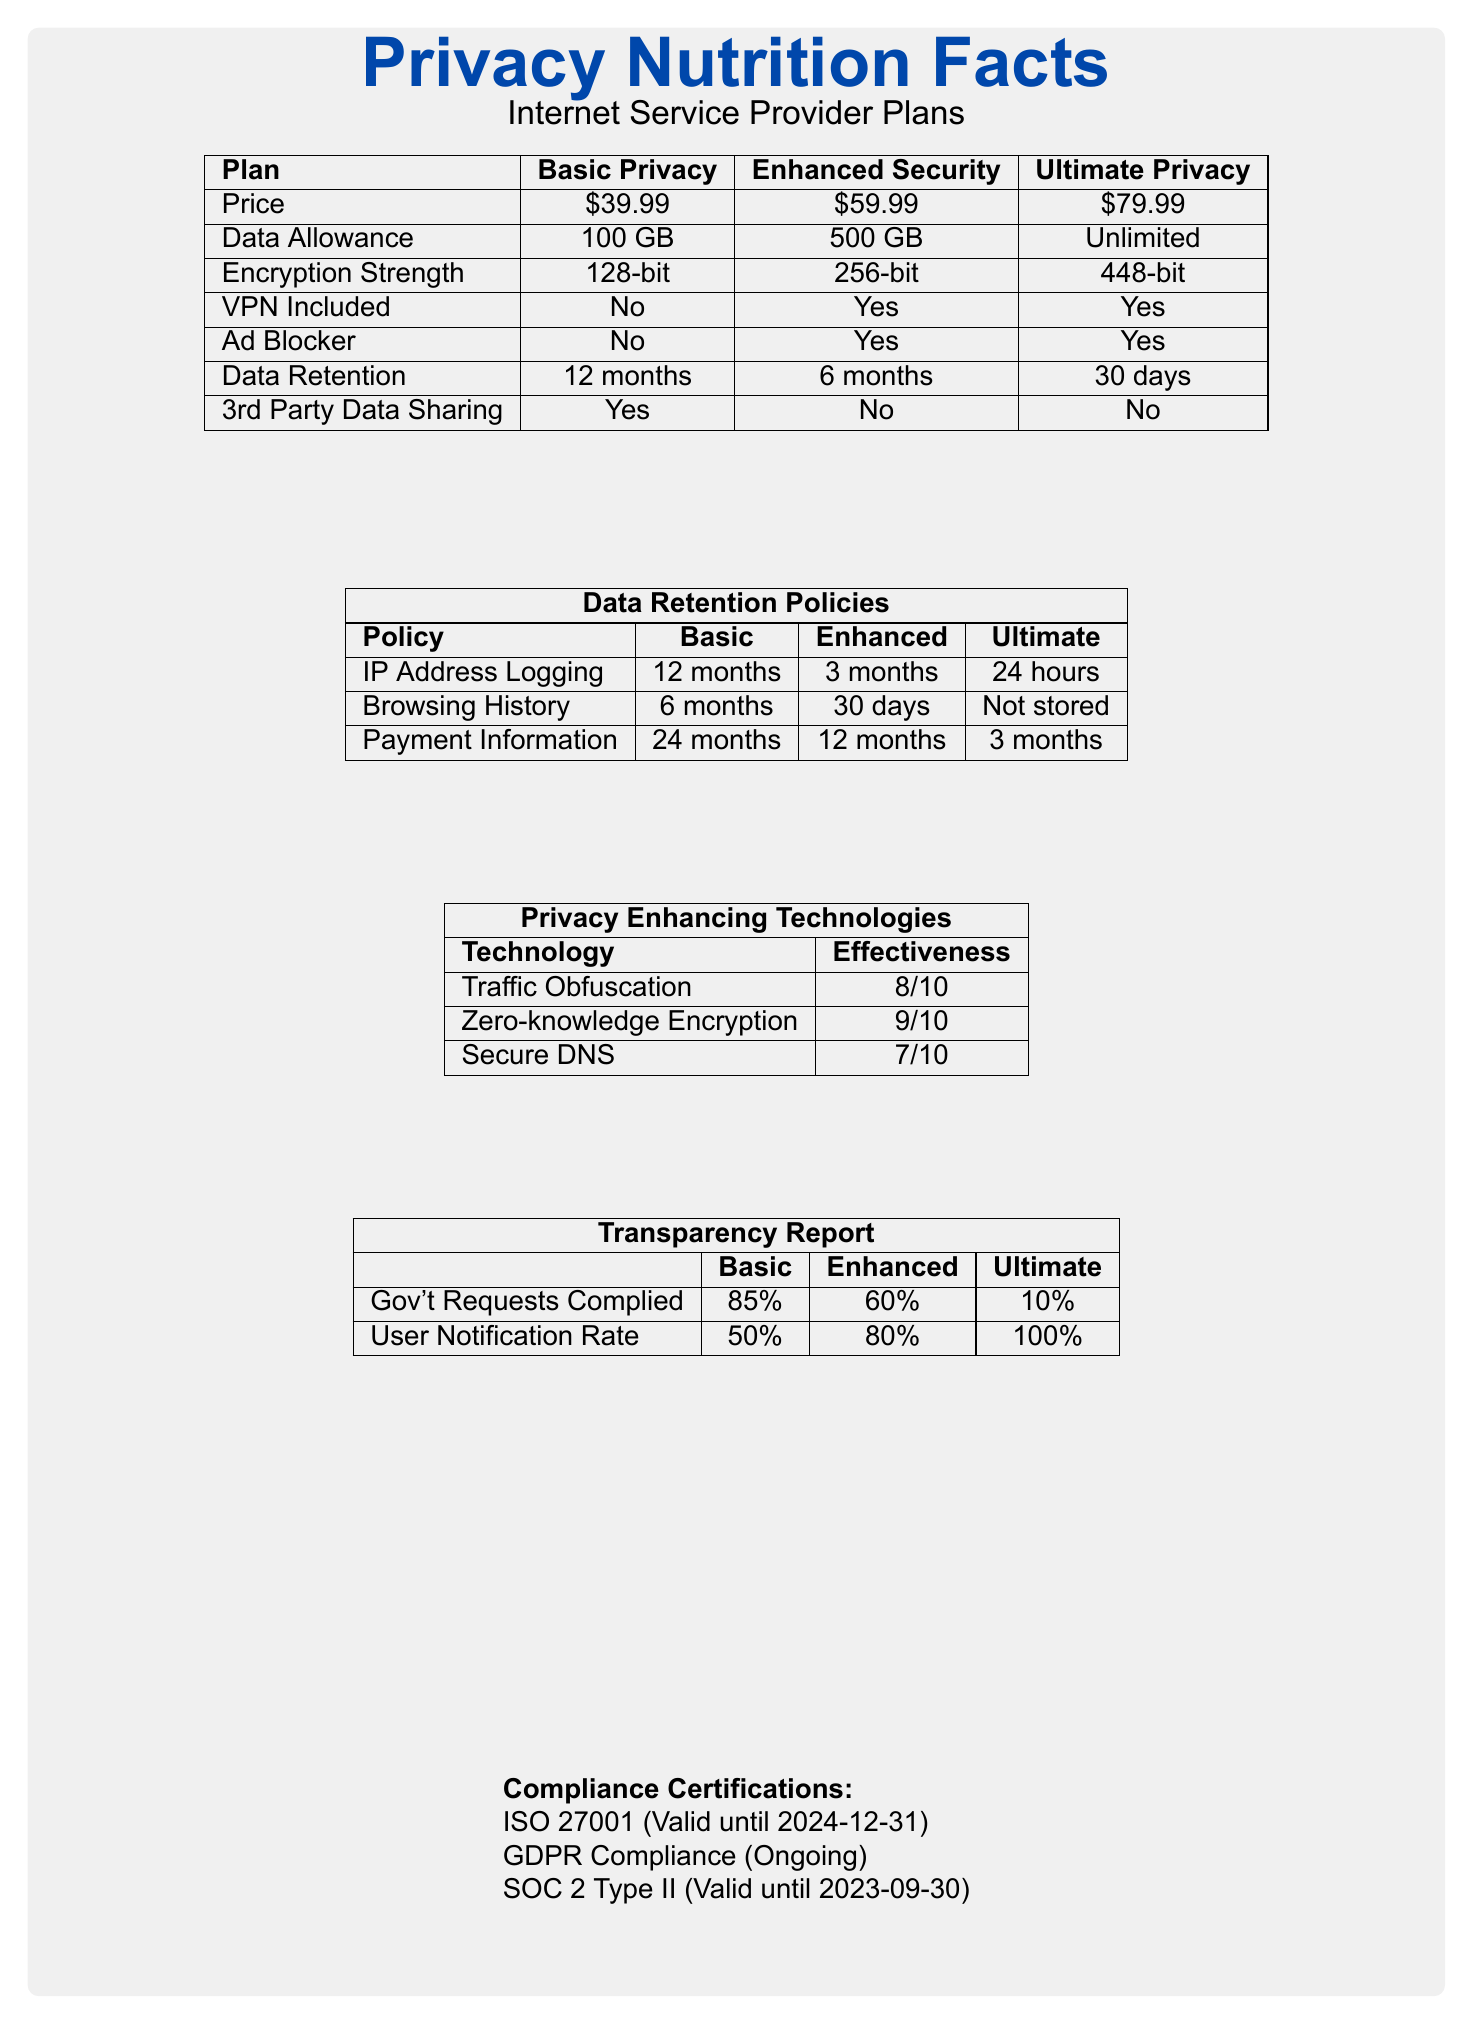What is the data allowance for the Basic Privacy plan? The data allowance for the Basic Privacy plan is specifically listed as 100 GB in the data chart under the "Data Allowance" row.
Answer: 100 GB Does the Enhanced Security plan include a VPN? The table clearly states that the Enhanced Security plan includes 'VPN Included' with a 'Yes' indicated.
Answer: Yes Which plan has the shortest data retention period? From the data chart, the Ultimate Privacy plan has the shortest data retention period of 30 days.
Answer: Ultimate Privacy Is third-party data sharing allowed in the Enhanced Security plan? The chart explicitly indicates 'No' for third-party data sharing under the Enhanced Security plan.
Answer: No How many months of payment information is retained under the Basic Privacy plan? The Data Retention Policies table shows that the Basic Privacy plan retains payment information for 24 months.
Answer: 24 months Which plans include the HTTPS Everywhere feature? A. Basic Privacy and Enhanced Security B. Ultimate Privacy and Enhanced Security C. Basic Privacy, Enhanced Security, and Ultimate Privacy D. Basic Privacy and Ultimate Privacy The document states that the HTTPS Everywhere feature is available in "Basic Privacy," "Enhanced Security," and "Ultimate Privacy."
Answer: C Which ISP plan has the highest government requests compliance percentage? A. Basic Privacy B. Enhanced Security C. Ultimate Privacy The Transparency Report section shows that the Basic Privacy plan has the highest government requests compliance rate at 85%.
Answer: A Does the Ultimate Privacy plan store browsing history? According to the Data Retention Policies, browsing history is not stored in the Ultimate Privacy plan.
Answer: No Describe the main features presented in the document. The description encapsulates key points concerning privacy and security features of different plans, technologies employed, and compliance certifications, offering a comprehensive view of privacy aspects in the ISP’s service plans.
Answer: The document presents a comparison of three internet service plans offered by an ISP, detailing their key privacy and security features, including data allowance, encryption strength, VPN inclusion, ad blocker availability, data retention periods, and third-party data sharing policies. It also outlines specific privacy-enhancing technologies, data retention policies for IP address logging, browsing history, and payment information, as well as a transparency report on government request compliance and user notification rates. Additionally, it lists compliance certifications relevant to the ISP. Which encryption strength is the highest among the plans? The encryption strength listed in the data chart for Ultimate Privacy is 448-bit, which is the highest among all plans.
Answer: 448-bit Is multi-hop VPN available in all plans? The privacy features section indicates that multi-hop VPN is only available in the Ultimate Privacy plan.
Answer: No Which plan complies least with government requests? From the Transparency Report, the Ultimate Privacy plan complies with only 10% of government requests, the lowest among the plans.
Answer: Ultimate Privacy Can we determine the exact effectiveness rating of DNS-over-HTTPS from the document? The document details the availability of DNS-over-HTTPS in certain plans but does not provide its effectiveness rating explicitly.
Answer: Not enough information What is the user notification rate for the Enhanced Security plan? The transparency report specifies that the user notification rate for the Enhanced Security plan is 80%.
Answer: 80% 